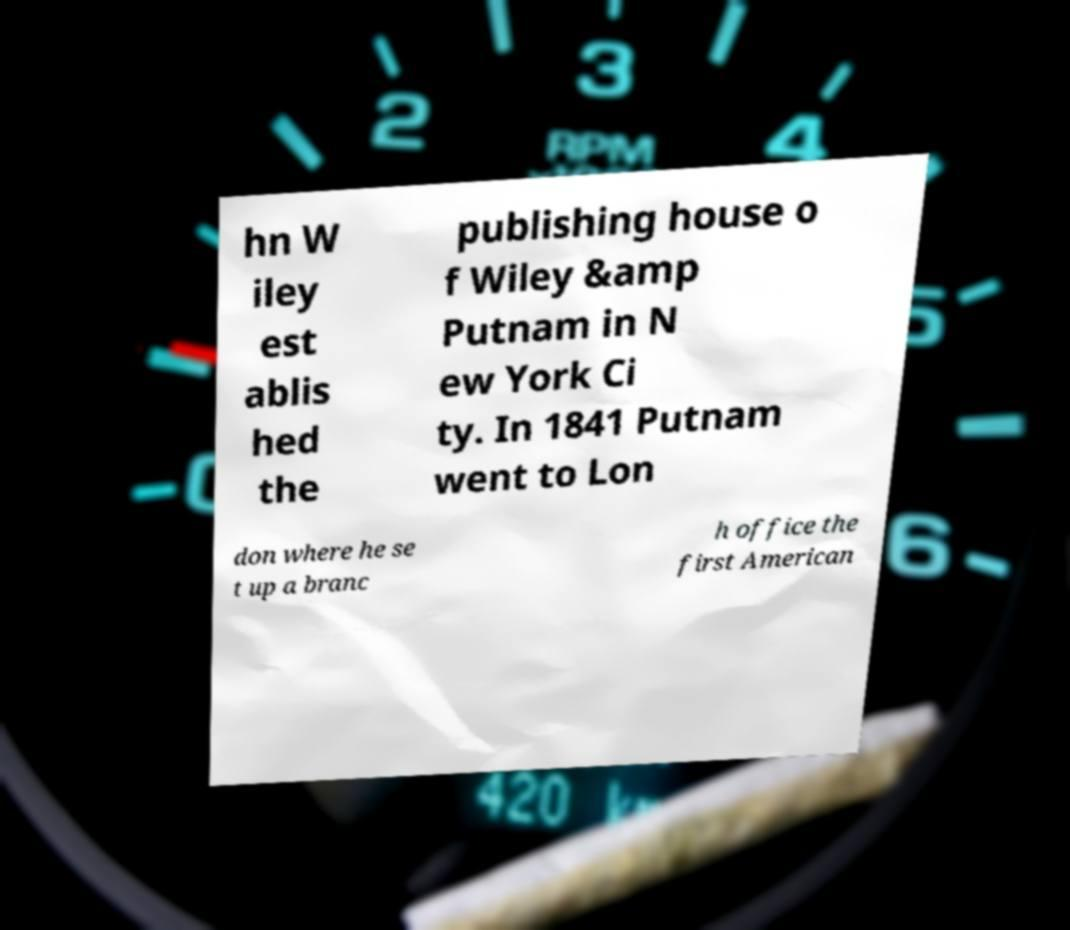I need the written content from this picture converted into text. Can you do that? hn W iley est ablis hed the publishing house o f Wiley &amp Putnam in N ew York Ci ty. In 1841 Putnam went to Lon don where he se t up a branc h office the first American 